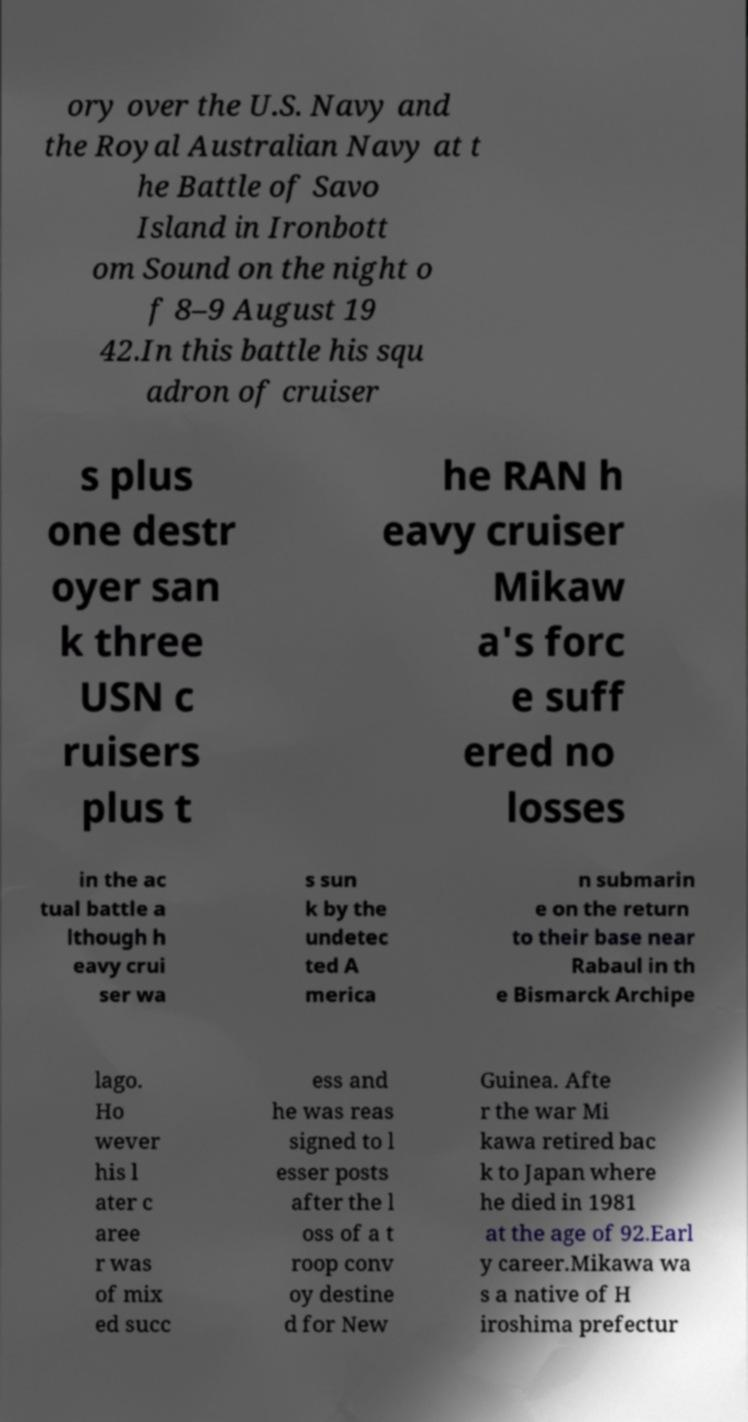Can you accurately transcribe the text from the provided image for me? ory over the U.S. Navy and the Royal Australian Navy at t he Battle of Savo Island in Ironbott om Sound on the night o f 8–9 August 19 42.In this battle his squ adron of cruiser s plus one destr oyer san k three USN c ruisers plus t he RAN h eavy cruiser Mikaw a's forc e suff ered no losses in the ac tual battle a lthough h eavy crui ser wa s sun k by the undetec ted A merica n submarin e on the return to their base near Rabaul in th e Bismarck Archipe lago. Ho wever his l ater c aree r was of mix ed succ ess and he was reas signed to l esser posts after the l oss of a t roop conv oy destine d for New Guinea. Afte r the war Mi kawa retired bac k to Japan where he died in 1981 at the age of 92.Earl y career.Mikawa wa s a native of H iroshima prefectur 